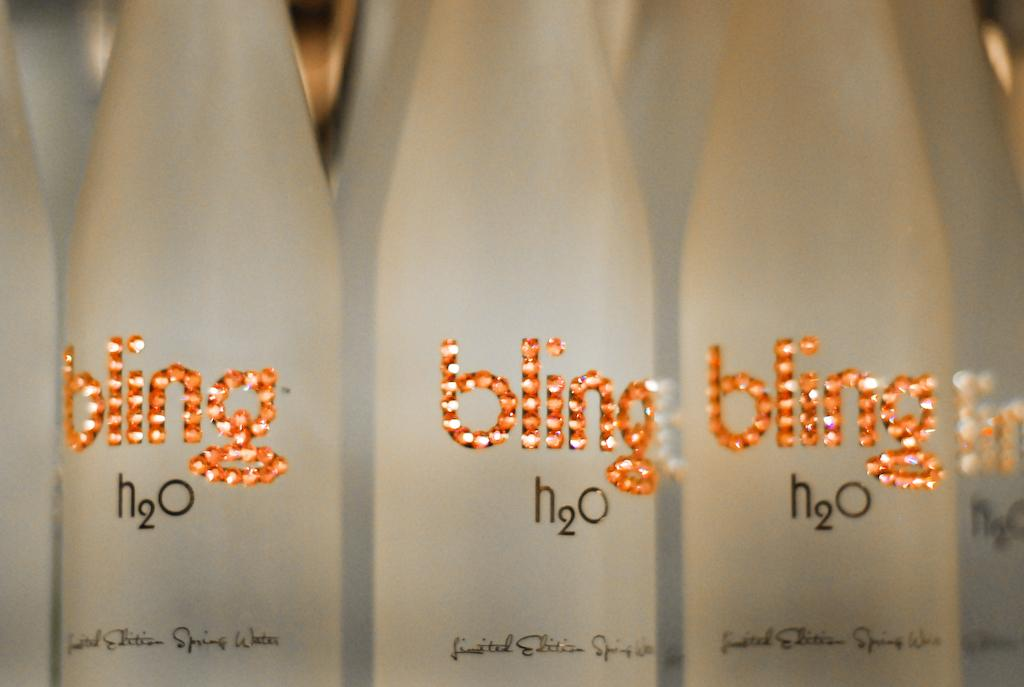Provide a one-sentence caption for the provided image. An orange and white lighted bling logo on a cloudy glass water bottle. 